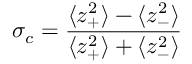Convert formula to latex. <formula><loc_0><loc_0><loc_500><loc_500>\sigma _ { c } = \frac { \langle z _ { + } ^ { 2 } \rangle - \langle z _ { - } ^ { 2 } \rangle } { \langle z _ { + } ^ { 2 } \rangle + \langle z _ { - } ^ { 2 } \rangle }</formula> 